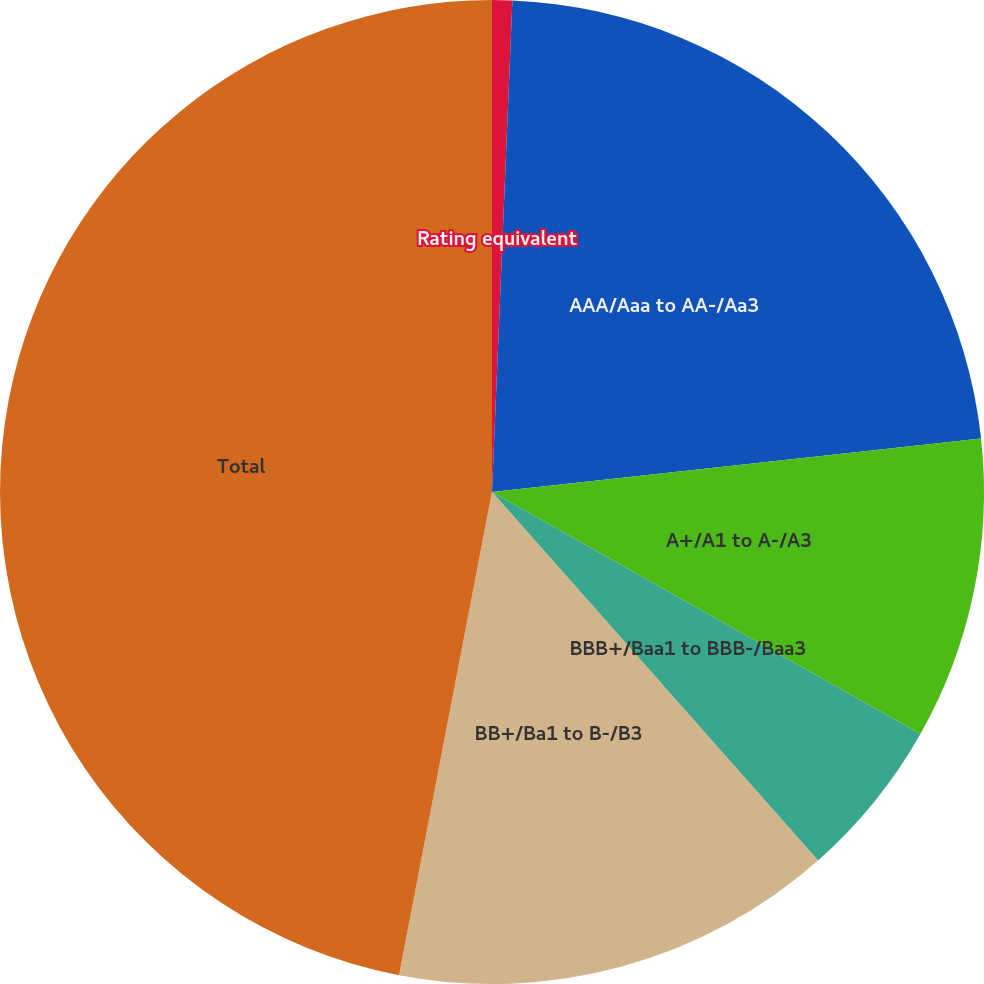Convert chart to OTSL. <chart><loc_0><loc_0><loc_500><loc_500><pie_chart><fcel>Rating equivalent<fcel>AAA/Aaa to AA-/Aa3<fcel>A+/A1 to A-/A3<fcel>BBB+/Baa1 to BBB-/Baa3<fcel>BB+/Ba1 to B-/B3<fcel>Total<nl><fcel>0.66%<fcel>22.6%<fcel>9.92%<fcel>5.29%<fcel>14.55%<fcel>46.97%<nl></chart> 